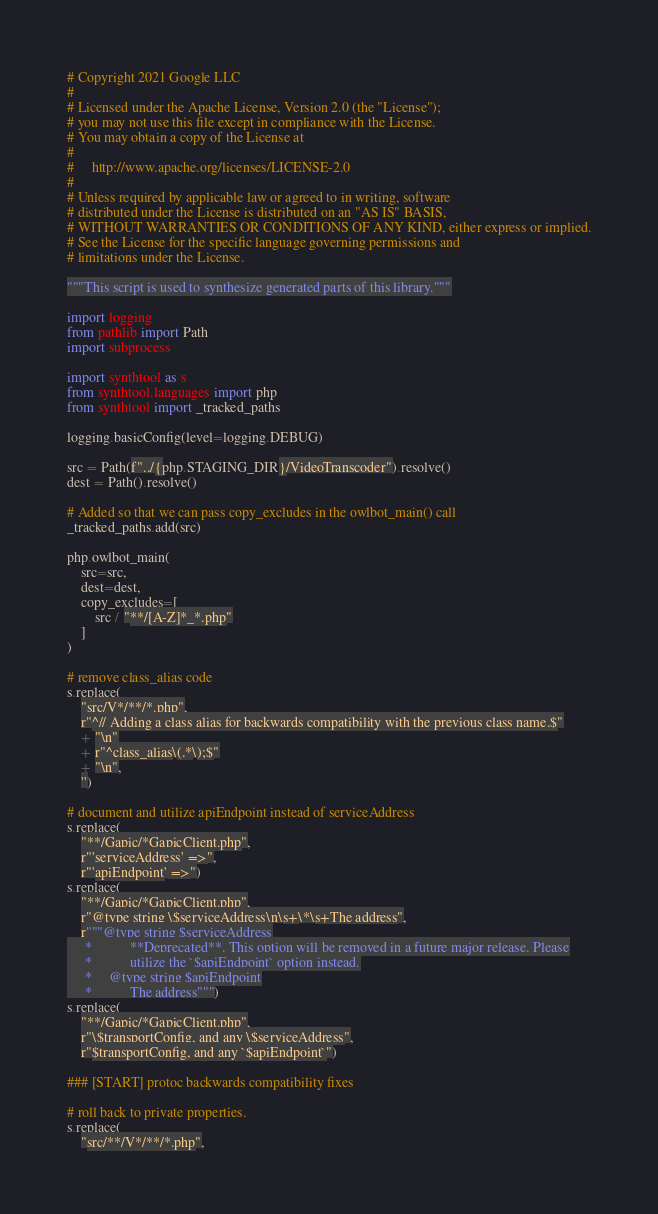Convert code to text. <code><loc_0><loc_0><loc_500><loc_500><_Python_># Copyright 2021 Google LLC
#
# Licensed under the Apache License, Version 2.0 (the "License");
# you may not use this file except in compliance with the License.
# You may obtain a copy of the License at
#
#     http://www.apache.org/licenses/LICENSE-2.0
#
# Unless required by applicable law or agreed to in writing, software
# distributed under the License is distributed on an "AS IS" BASIS,
# WITHOUT WARRANTIES OR CONDITIONS OF ANY KIND, either express or implied.
# See the License for the specific language governing permissions and
# limitations under the License.

"""This script is used to synthesize generated parts of this library."""

import logging
from pathlib import Path
import subprocess

import synthtool as s
from synthtool.languages import php
from synthtool import _tracked_paths

logging.basicConfig(level=logging.DEBUG)

src = Path(f"../{php.STAGING_DIR}/VideoTranscoder").resolve()
dest = Path().resolve()

# Added so that we can pass copy_excludes in the owlbot_main() call
_tracked_paths.add(src)

php.owlbot_main(
    src=src,
    dest=dest,
    copy_excludes=[
        src / "**/[A-Z]*_*.php"
    ]
)

# remove class_alias code
s.replace(
    "src/V*/**/*.php",
    r"^// Adding a class alias for backwards compatibility with the previous class name.$"
    + "\n"
    + r"^class_alias\(.*\);$"
    + "\n",
    '')

# document and utilize apiEndpoint instead of serviceAddress
s.replace(
    "**/Gapic/*GapicClient.php",
    r"'serviceAddress' =>",
    r"'apiEndpoint' =>")
s.replace(
    "**/Gapic/*GapicClient.php",
    r"@type string \$serviceAddress\n\s+\*\s+The address",
    r"""@type string $serviceAddress
     *           **Deprecated**. This option will be removed in a future major release. Please
     *           utilize the `$apiEndpoint` option instead.
     *     @type string $apiEndpoint
     *           The address""")
s.replace(
    "**/Gapic/*GapicClient.php",
    r"\$transportConfig, and any \$serviceAddress",
    r"$transportConfig, and any `$apiEndpoint`")

### [START] protoc backwards compatibility fixes

# roll back to private properties.
s.replace(
    "src/**/V*/**/*.php",</code> 